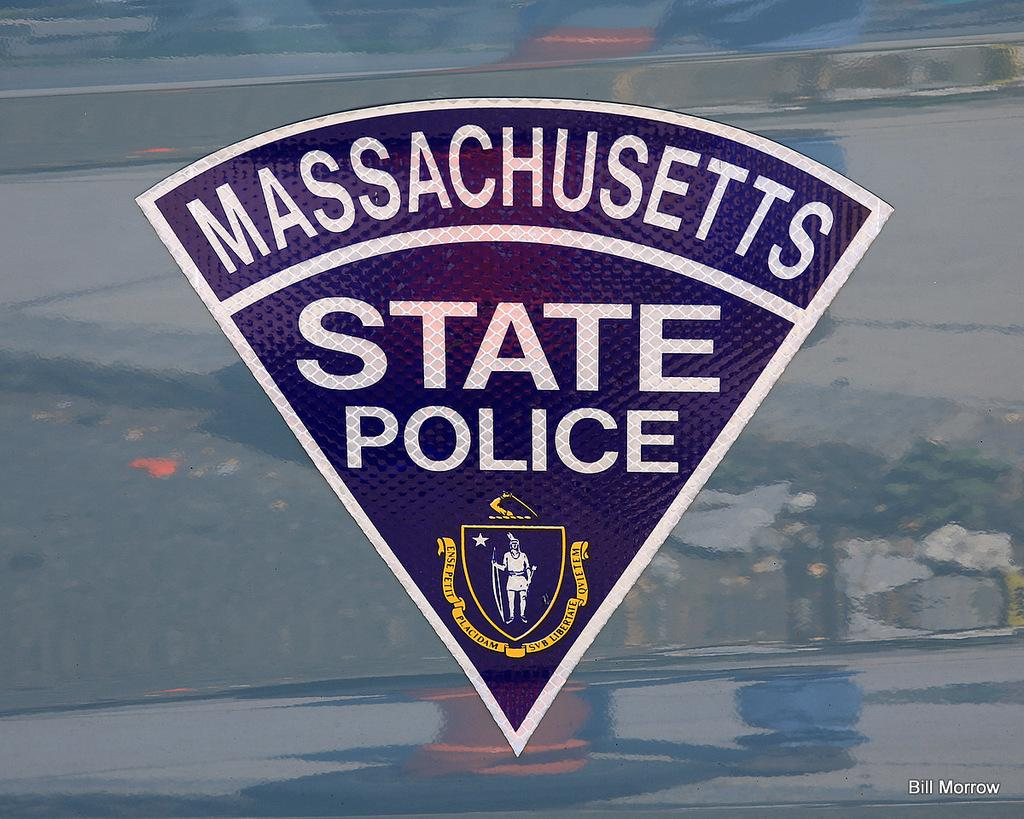What is the main feature in the center of the image? There is a logo with some text in the center of the image. How would you describe the background of the image? The background of the image is blurred. Is there any text present in the image besides the logo? Yes, there is some text in the bottom right corner of the image. How many eggs are being sold at the market in the image? There is no market or eggs present in the image; it only features a logo with some text and a blurred background. 